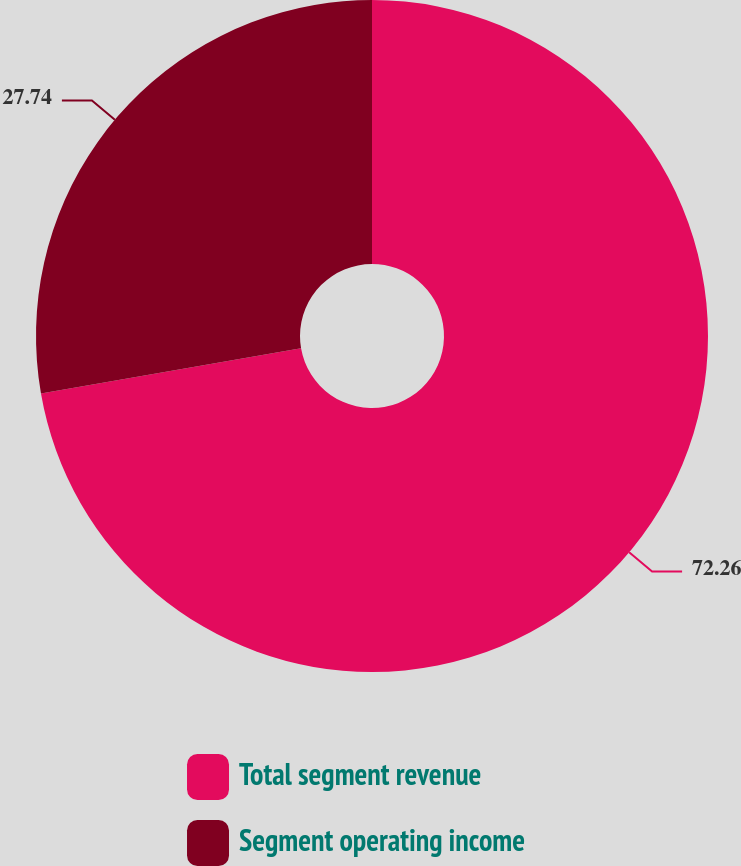Convert chart. <chart><loc_0><loc_0><loc_500><loc_500><pie_chart><fcel>Total segment revenue<fcel>Segment operating income<nl><fcel>72.26%<fcel>27.74%<nl></chart> 